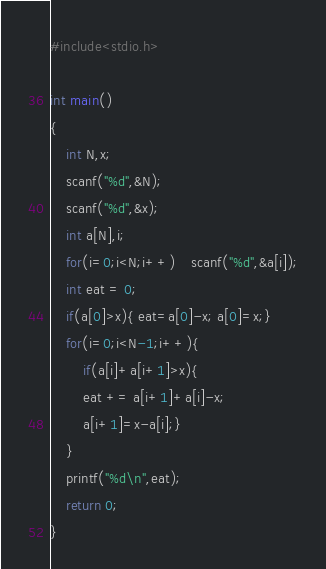Convert code to text. <code><loc_0><loc_0><loc_500><loc_500><_C_>#include<stdio.h>

int main()
{
	int N,x;
	scanf("%d",&N);
	scanf("%d",&x);
	int a[N],i;
	for(i=0;i<N;i++) 	scanf("%d",&a[i]);
	int eat = 0;
	if(a[0]>x){ eat=a[0]-x; a[0]=x;}
	for(i=0;i<N-1;i++){
		if(a[i]+a[i+1]>x){
		eat += a[i+1]+a[i]-x;
		a[i+1]=x-a[i];}
	}
	printf("%d\n",eat);
	return 0;
}</code> 